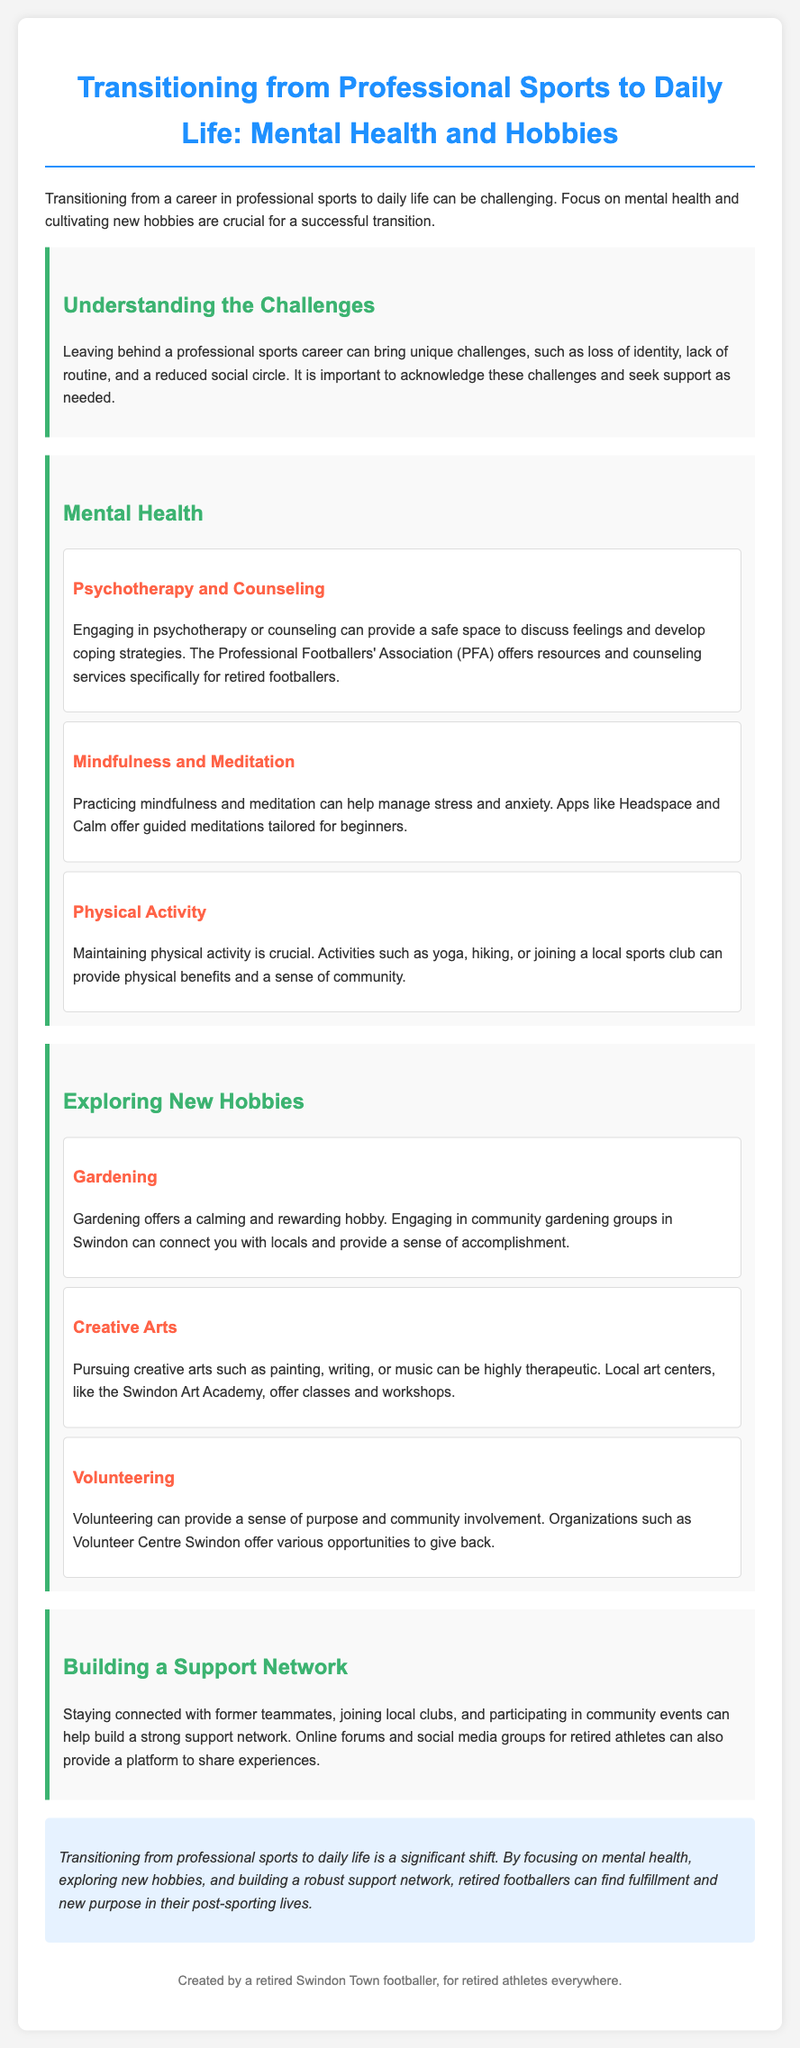What is the title of the document? The title is prominently displayed at the top of the document, indicating the subject of the lesson.
Answer: Transitioning from Professional Sports to Daily Life: Mental Health and Hobbies What organization offers resources for retired footballers? The document mentions the Professional Footballers' Association specifically for retired athletes.
Answer: Professional Footballers' Association Name one mental health practice mentioned in the document. The document outlines several practices for mental health; one example is highlighted in its own subsection.
Answer: Mindfulness and Meditation What hobby is suggested for community involvement? The document lists various hobbies, and one in particular emphasizes the aspect of community service.
Answer: Volunteering Which local art center is mentioned? The document specifies a local place that offers arts classes and workshops.
Answer: Swindon Art Academy Why is maintaining physical activity important? The text identifies the benefits of staying physically active and how it contributes to mental well-being.
Answer: Crucial What can retired footballers develop through psychotherapy or counseling? The document discusses the role of counseling in managing emotions during the transition phase.
Answer: Coping strategies What is one suggested outdoor activity? One activity highlighted for maintaining physical engagement and community connection is mentioned.
Answer: Hiking What is a key aspect for a successful transition mentioned in the conclusion? The concluding section refers to multiple strategies for adapting to life after sports.
Answer: Building a robust support network 